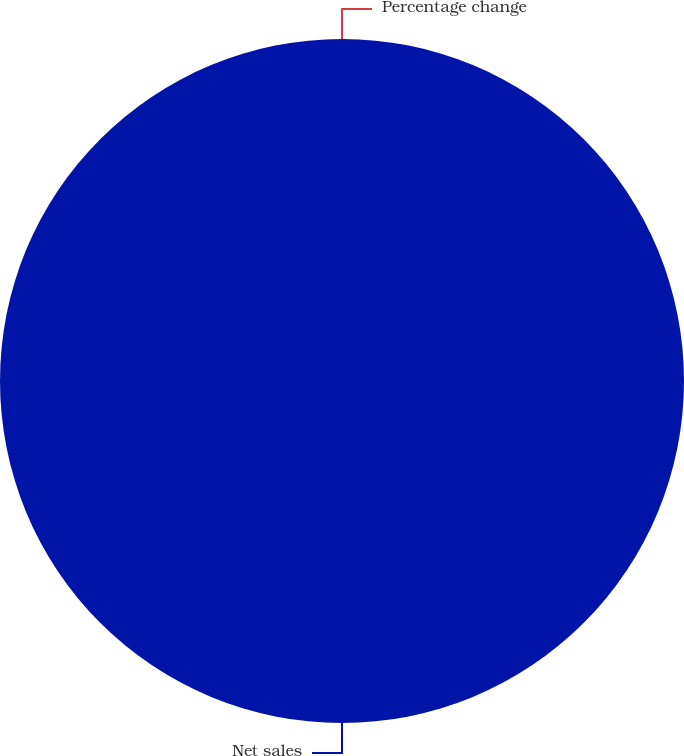Convert chart to OTSL. <chart><loc_0><loc_0><loc_500><loc_500><pie_chart><fcel>Net sales<fcel>Percentage change<nl><fcel>100.0%<fcel>0.0%<nl></chart> 